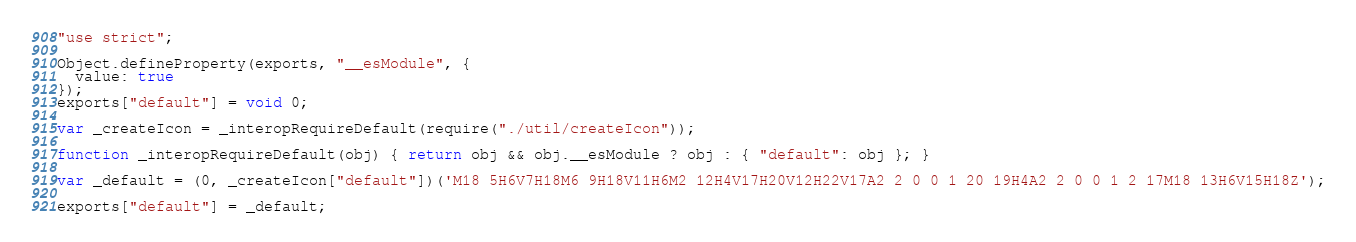Convert code to text. <code><loc_0><loc_0><loc_500><loc_500><_JavaScript_>"use strict";

Object.defineProperty(exports, "__esModule", {
  value: true
});
exports["default"] = void 0;

var _createIcon = _interopRequireDefault(require("./util/createIcon"));

function _interopRequireDefault(obj) { return obj && obj.__esModule ? obj : { "default": obj }; }

var _default = (0, _createIcon["default"])('M18 5H6V7H18M6 9H18V11H6M2 12H4V17H20V12H22V17A2 2 0 0 1 20 19H4A2 2 0 0 1 2 17M18 13H6V15H18Z');

exports["default"] = _default;</code> 